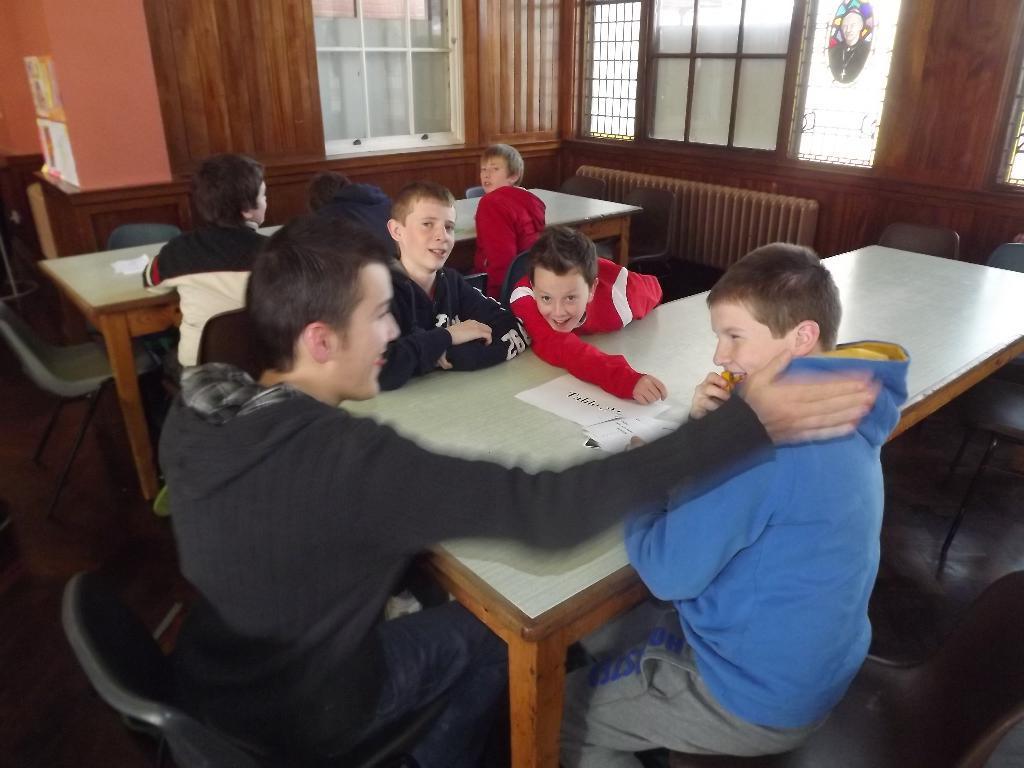Could you give a brief overview of what you see in this image? In the image in the center we can see few persons were sitting around the table. And they were smiling and coming to the background we can see window and wall. 